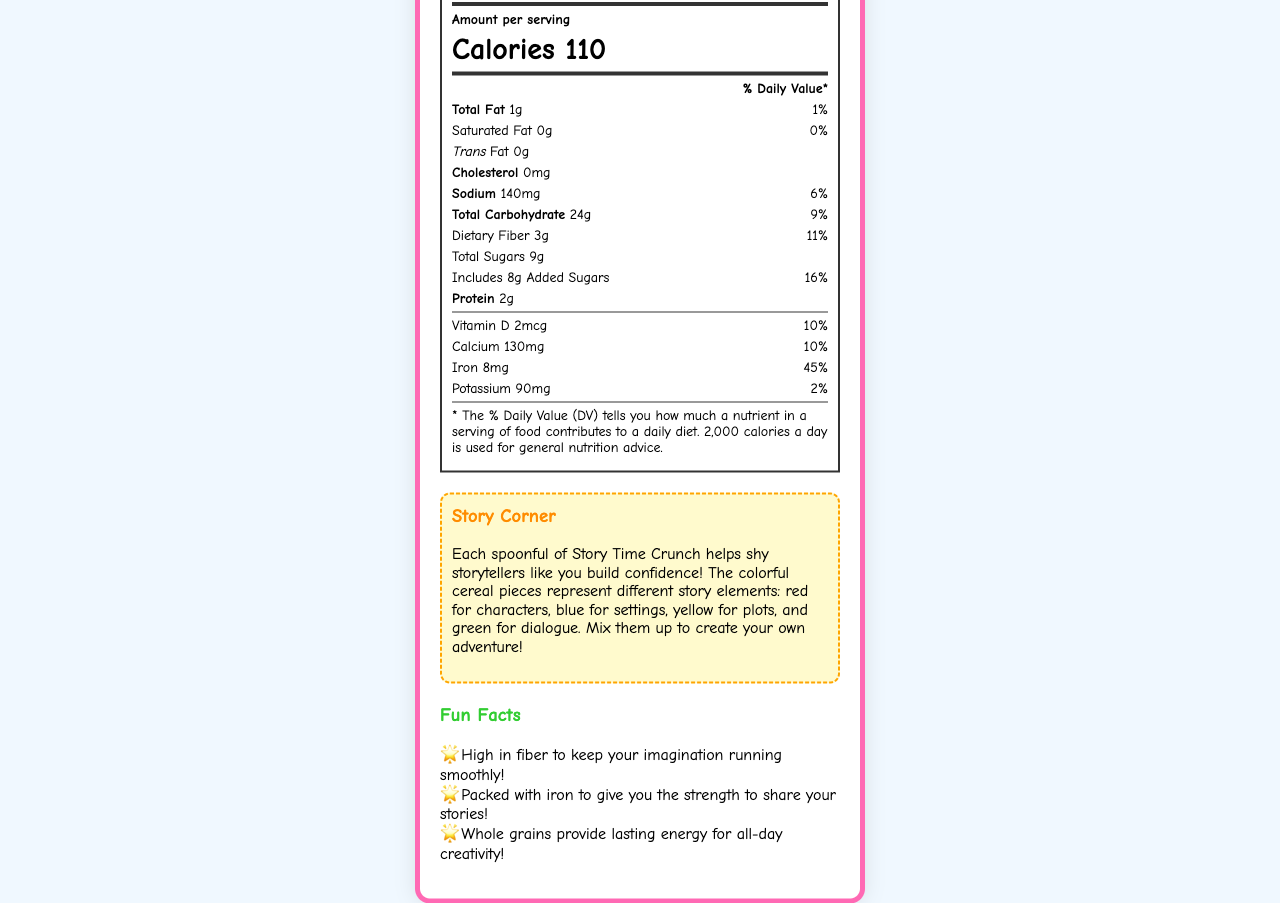what is the serving size of Story Time Crunch? The serving size is directly stated as "3/4 cup (30g)" on the nutrition label.
Answer: 3/4 cup (30g) how many calories are in one serving? The document states that each serving contains 110 calories.
Answer: 110 what is the daily value percentage for total fat? The daily value percentage for total fat is provided as "1%" on the label.
Answer: 1% how much dietary fiber is in one serving? The amount of dietary fiber per serving is listed as "3g."
Answer: 3g which vitamin or mineral has the highest daily value percentage? Iron has the highest daily value percentage at 45%, which is clearly stated in the document.
Answer: Iron how many servings are in one container? The label indicates there are "about 12" servings per container.
Answer: about 12 what are the first three ingredients listed? The first three ingredients are listed as "Whole grain oats, Corn flour, Sugar."
Answer: Whole grain oats, Corn flour, Sugar what is the name of the mascot for this cereal? The mascot's name is given as "Paige the Brave Bookworm."
Answer: Paige the Brave Bookworm how much sodium is in one serving? The nutrition label shows that there is 140mg of sodium per serving.
Answer: 140mg what is the % daily value of vitamin D? The % daily value of vitamin D is listed as 10%.
Answer: 10% which nutrient contributes 16% to the daily value? Added sugars contribute 16% to the daily value as stated on the label.
Answer: Added sugars what does the yellow cereal piece in Story Time Crunch represent? The story corner explains that the yellow cereal pieces represent plots.
Answer: Plots summary: Describe the main idea of the document The document details the nutritional information for Story Time Crunch cereal, including serving size, calorie content, and daily value percentages of various nutrients. It also incorporates creative elements to engage children, such as color-coded cereal pieces representing story elements, and a character mascot named Paige the Brave Bookworm.
Answer: The main idea of the document is to provide the nutrition facts for Story Time Crunch cereal, emphasizing its fiber and iron content. It highlights the serving size, calorie count, and percentages of daily values of different nutrients, including vitamins and minerals. The document also includes playful elements like Story Corner and Fun Facts, along with a character mascot to encourage storytelling and creativity in kids. how many grams of protein are in one serving of Story Time Crunch? The label states that each serving contains 2 grams of protein.
Answer: 2g which of the following vitamins is included in Story Time Crunch? A. Vitamin A B. Vitamin E C. Vitamin D D. Vitamin K The label lists Vitamin D as one of the included vitamins.
Answer: C. Vitamin D how much calcium is present per serving? The nutrition label shows that each serving contains 130mg of calcium.
Answer: 130mg does Story Time Crunch contain any trans fat? The label clearly states that there is 0g of Trans Fat per serving.
Answer: No can you determine the manufacturer based on the document? The manufacturer is mentioned as "Imagination Foods, Inc." on the document.
Answer: Yes, it is Imagination Foods, Inc. does this cereal product contain allergies to wheat? The allergen information states that the product contains wheat ingredients.
Answer: Yes what is the website for Story Time Crunch? The document provides the website as "www.storytimecrunch.com."
Answer: www.storytimecrunch.com are there any animal products in the ingredient list? The document doesn't specify whether the ingredient "Vitamin E (mixed tocopherols)" or any other ingredient is derived from animal sources, making it unclear.
Answer: Not enough information 